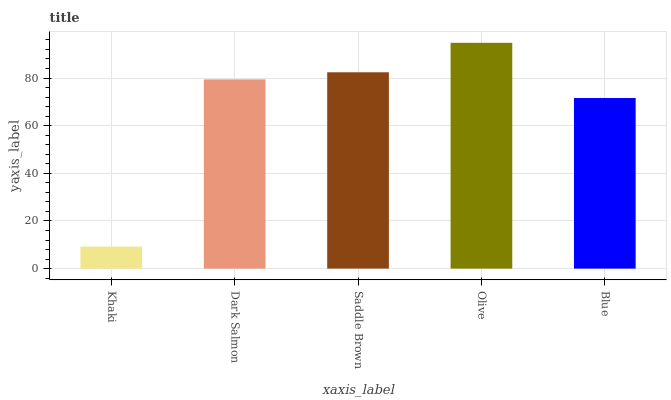Is Khaki the minimum?
Answer yes or no. Yes. Is Olive the maximum?
Answer yes or no. Yes. Is Dark Salmon the minimum?
Answer yes or no. No. Is Dark Salmon the maximum?
Answer yes or no. No. Is Dark Salmon greater than Khaki?
Answer yes or no. Yes. Is Khaki less than Dark Salmon?
Answer yes or no. Yes. Is Khaki greater than Dark Salmon?
Answer yes or no. No. Is Dark Salmon less than Khaki?
Answer yes or no. No. Is Dark Salmon the high median?
Answer yes or no. Yes. Is Dark Salmon the low median?
Answer yes or no. Yes. Is Olive the high median?
Answer yes or no. No. Is Olive the low median?
Answer yes or no. No. 